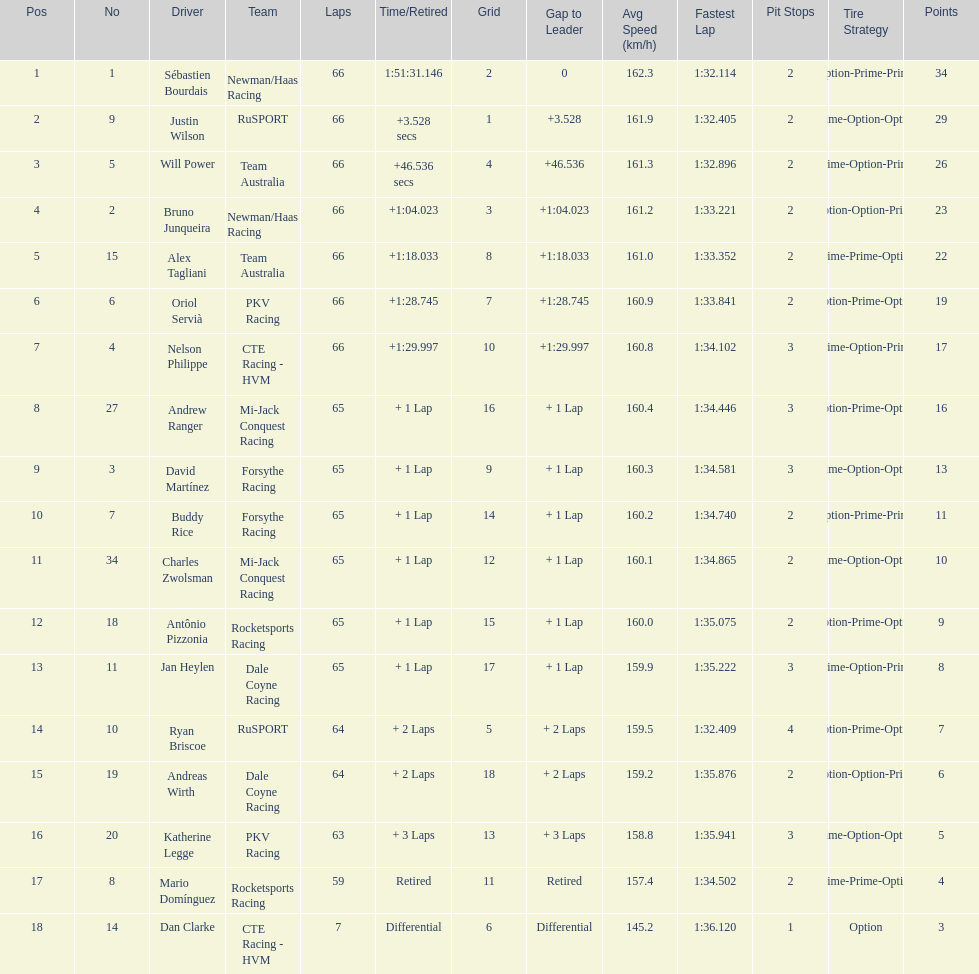At the 2006 gran premio telmex, who finished last? Dan Clarke. Parse the table in full. {'header': ['Pos', 'No', 'Driver', 'Team', 'Laps', 'Time/Retired', 'Grid', 'Gap to Leader', 'Avg Speed (km/h)', 'Fastest Lap', 'Pit Stops', 'Tire Strategy', 'Points'], 'rows': [['1', '1', 'Sébastien Bourdais', 'Newman/Haas Racing', '66', '1:51:31.146', '2', '0', '162.3', '1:32.114', '2', 'Option-Prime-Prime', '34'], ['2', '9', 'Justin Wilson', 'RuSPORT', '66', '+3.528 secs', '1', '+3.528', '161.9', '1:32.405', '2', 'Prime-Option-Option', '29'], ['3', '5', 'Will Power', 'Team Australia', '66', '+46.536 secs', '4', '+46.536', '161.3', '1:32.896', '2', 'Prime-Option-Prime', '26'], ['4', '2', 'Bruno Junqueira', 'Newman/Haas Racing', '66', '+1:04.023', '3', '+1:04.023', '161.2', '1:33.221', '2', 'Option-Option-Prime', '23'], ['5', '15', 'Alex Tagliani', 'Team Australia', '66', '+1:18.033', '8', '+1:18.033', '161.0', '1:33.352', '2', 'Prime-Prime-Option', '22'], ['6', '6', 'Oriol Servià', 'PKV Racing', '66', '+1:28.745', '7', '+1:28.745', '160.9', '1:33.841', '2', 'Option-Prime-Option', '19'], ['7', '4', 'Nelson Philippe', 'CTE Racing - HVM', '66', '+1:29.997', '10', '+1:29.997', '160.8', '1:34.102', '3', 'Prime-Option-Prime', '17'], ['8', '27', 'Andrew Ranger', 'Mi-Jack Conquest Racing', '65', '+ 1 Lap', '16', '+ 1 Lap', '160.4', '1:34.446', '3', 'Option-Prime-Option', '16'], ['9', '3', 'David Martínez', 'Forsythe Racing', '65', '+ 1 Lap', '9', '+ 1 Lap', '160.3', '1:34.581', '3', 'Prime-Option-Option', '13'], ['10', '7', 'Buddy Rice', 'Forsythe Racing', '65', '+ 1 Lap', '14', '+ 1 Lap', '160.2', '1:34.740', '2', 'Option-Prime-Prime', '11'], ['11', '34', 'Charles Zwolsman', 'Mi-Jack Conquest Racing', '65', '+ 1 Lap', '12', '+ 1 Lap', '160.1', '1:34.865', '2', 'Prime-Option-Option', '10'], ['12', '18', 'Antônio Pizzonia', 'Rocketsports Racing', '65', '+ 1 Lap', '15', '+ 1 Lap', '160.0', '1:35.075', '2', 'Option-Prime-Option', '9'], ['13', '11', 'Jan Heylen', 'Dale Coyne Racing', '65', '+ 1 Lap', '17', '+ 1 Lap', '159.9', '1:35.222', '3', 'Prime-Option-Prime', '8'], ['14', '10', 'Ryan Briscoe', 'RuSPORT', '64', '+ 2 Laps', '5', '+ 2 Laps', '159.5', '1:32.409', '4', 'Option-Prime-Option', '7'], ['15', '19', 'Andreas Wirth', 'Dale Coyne Racing', '64', '+ 2 Laps', '18', '+ 2 Laps', '159.2', '1:35.876', '2', 'Option-Option-Prime', '6'], ['16', '20', 'Katherine Legge', 'PKV Racing', '63', '+ 3 Laps', '13', '+ 3 Laps', '158.8', '1:35.941', '3', 'Prime-Option-Option', '5'], ['17', '8', 'Mario Domínguez', 'Rocketsports Racing', '59', 'Retired', '11', 'Retired', '157.4', '1:34.502', '2', 'Prime-Prime-Option', '4'], ['18', '14', 'Dan Clarke', 'CTE Racing - HVM', '7', 'Differential', '6', 'Differential', '145.2', '1:36.120', '1', 'Option', '3']]} 